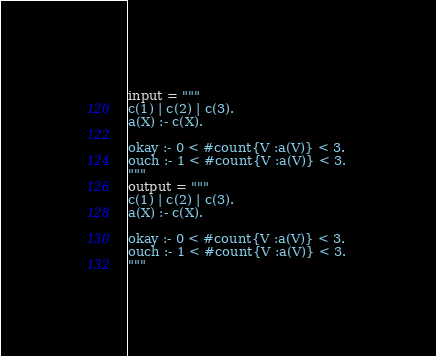<code> <loc_0><loc_0><loc_500><loc_500><_Python_>input = """
c(1) | c(2) | c(3).
a(X) :- c(X).

okay :- 0 < #count{V :a(V)} < 3. 
ouch :- 1 < #count{V :a(V)} < 3.
"""
output = """
c(1) | c(2) | c(3).
a(X) :- c(X).

okay :- 0 < #count{V :a(V)} < 3. 
ouch :- 1 < #count{V :a(V)} < 3.
"""
</code> 